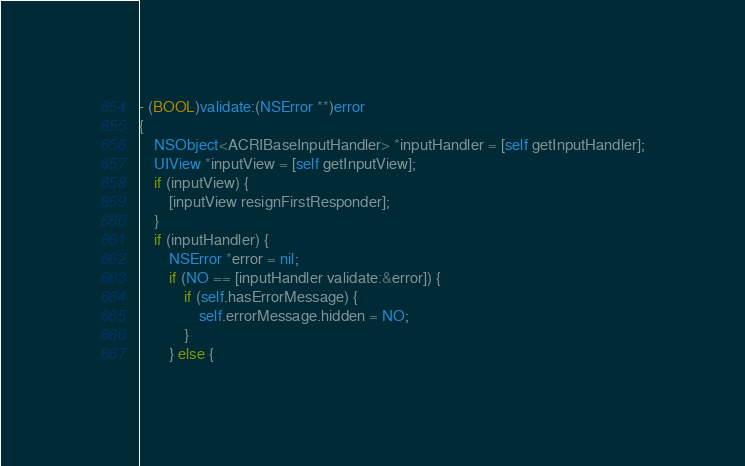Convert code to text. <code><loc_0><loc_0><loc_500><loc_500><_ObjectiveC_>- (BOOL)validate:(NSError **)error
{
    NSObject<ACRIBaseInputHandler> *inputHandler = [self getInputHandler];
    UIView *inputView = [self getInputView];
    if (inputView) {
        [inputView resignFirstResponder];
    }
    if (inputHandler) {
        NSError *error = nil;
        if (NO == [inputHandler validate:&error]) {
            if (self.hasErrorMessage) {
                self.errorMessage.hidden = NO;
            }
        } else {</code> 